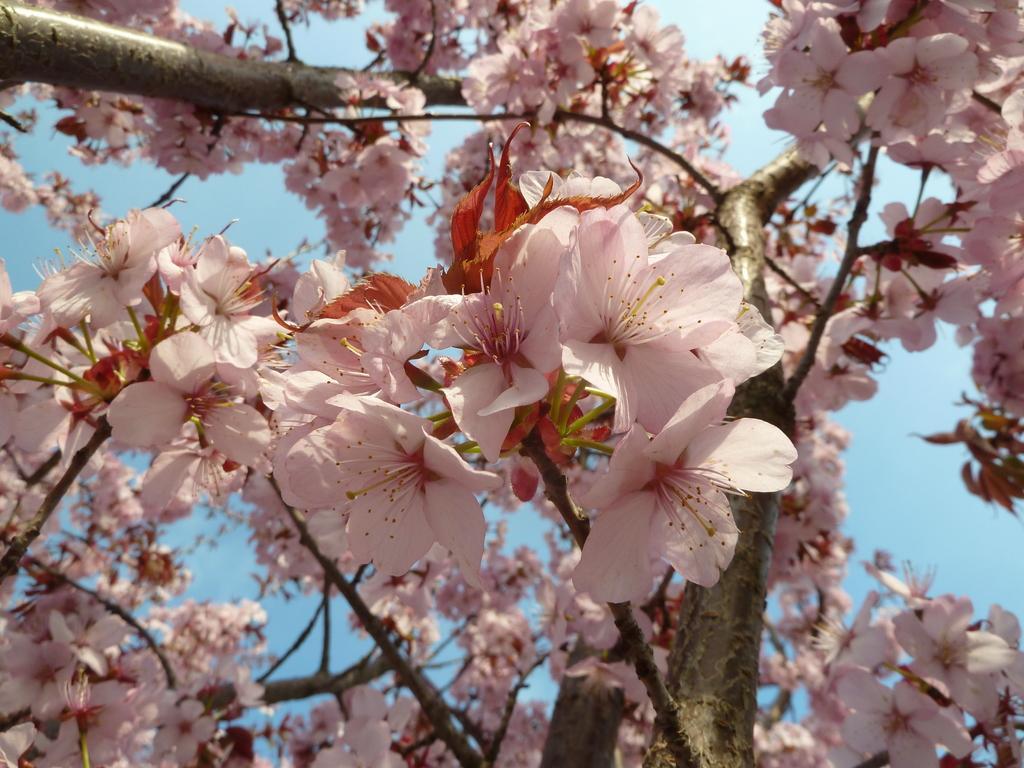Can you describe this image briefly? In this image, we can see some flowers. 